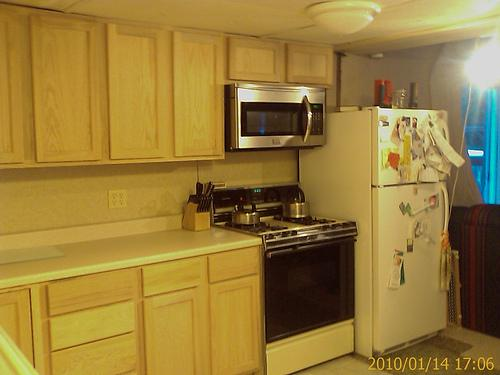What household food might you find in the object on the right? milk 